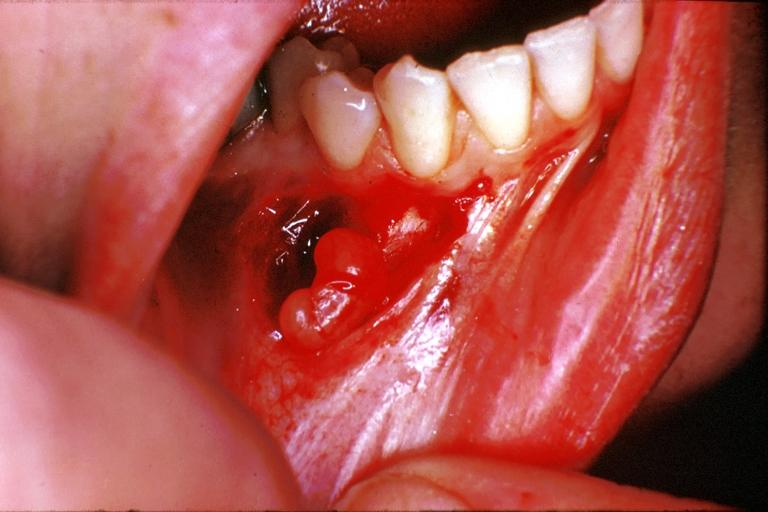what is present?
Answer the question using a single word or phrase. Oral 